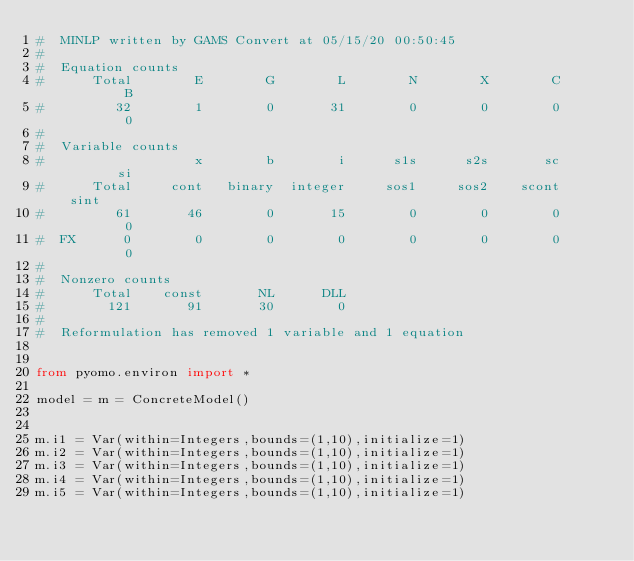<code> <loc_0><loc_0><loc_500><loc_500><_Python_>#  MINLP written by GAMS Convert at 05/15/20 00:50:45
#  
#  Equation counts
#      Total        E        G        L        N        X        C        B
#         32        1        0       31        0        0        0        0
#  
#  Variable counts
#                   x        b        i      s1s      s2s       sc       si
#      Total     cont   binary  integer     sos1     sos2    scont     sint
#         61       46        0       15        0        0        0        0
#  FX      0        0        0        0        0        0        0        0
#  
#  Nonzero counts
#      Total    const       NL      DLL
#        121       91       30        0
# 
#  Reformulation has removed 1 variable and 1 equation


from pyomo.environ import *

model = m = ConcreteModel()


m.i1 = Var(within=Integers,bounds=(1,10),initialize=1)
m.i2 = Var(within=Integers,bounds=(1,10),initialize=1)
m.i3 = Var(within=Integers,bounds=(1,10),initialize=1)
m.i4 = Var(within=Integers,bounds=(1,10),initialize=1)
m.i5 = Var(within=Integers,bounds=(1,10),initialize=1)</code> 